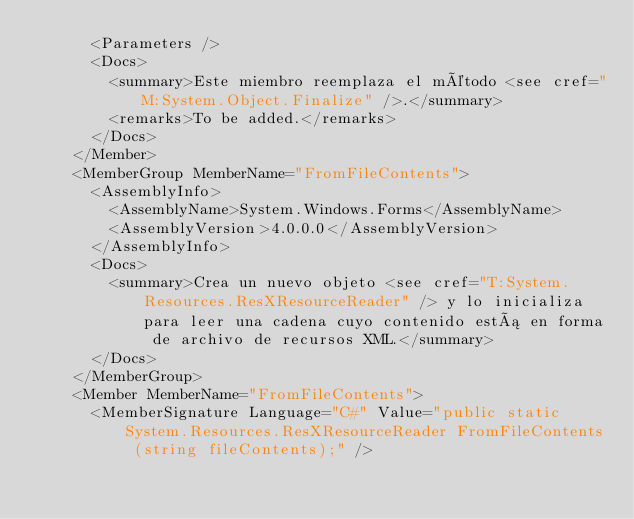Convert code to text. <code><loc_0><loc_0><loc_500><loc_500><_XML_>      <Parameters />
      <Docs>
        <summary>Este miembro reemplaza el método <see cref="M:System.Object.Finalize" />.</summary>
        <remarks>To be added.</remarks>
      </Docs>
    </Member>
    <MemberGroup MemberName="FromFileContents">
      <AssemblyInfo>
        <AssemblyName>System.Windows.Forms</AssemblyName>
        <AssemblyVersion>4.0.0.0</AssemblyVersion>
      </AssemblyInfo>
      <Docs>
        <summary>Crea un nuevo objeto <see cref="T:System.Resources.ResXResourceReader" /> y lo inicializa para leer una cadena cuyo contenido está en forma de archivo de recursos XML.</summary>
      </Docs>
    </MemberGroup>
    <Member MemberName="FromFileContents">
      <MemberSignature Language="C#" Value="public static System.Resources.ResXResourceReader FromFileContents (string fileContents);" /></code> 